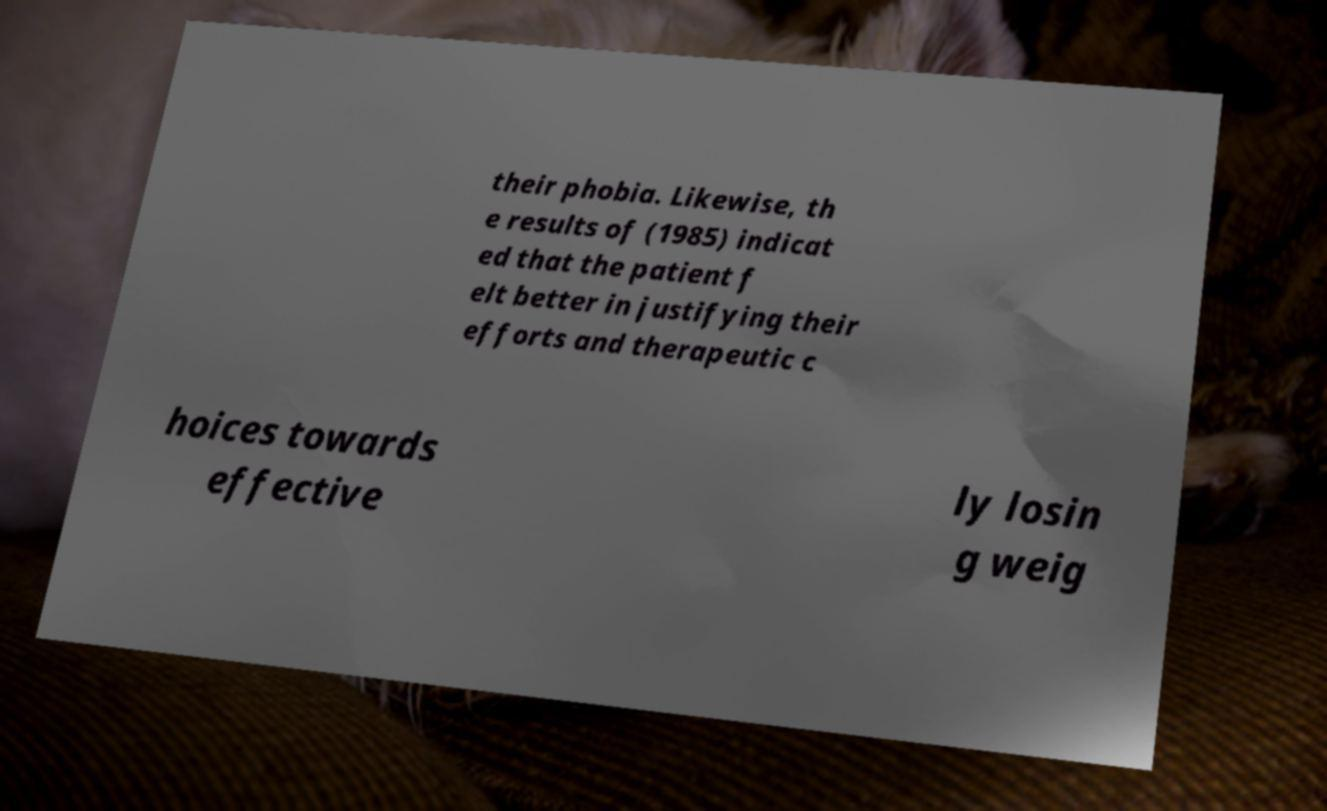Could you extract and type out the text from this image? their phobia. Likewise, th e results of (1985) indicat ed that the patient f elt better in justifying their efforts and therapeutic c hoices towards effective ly losin g weig 